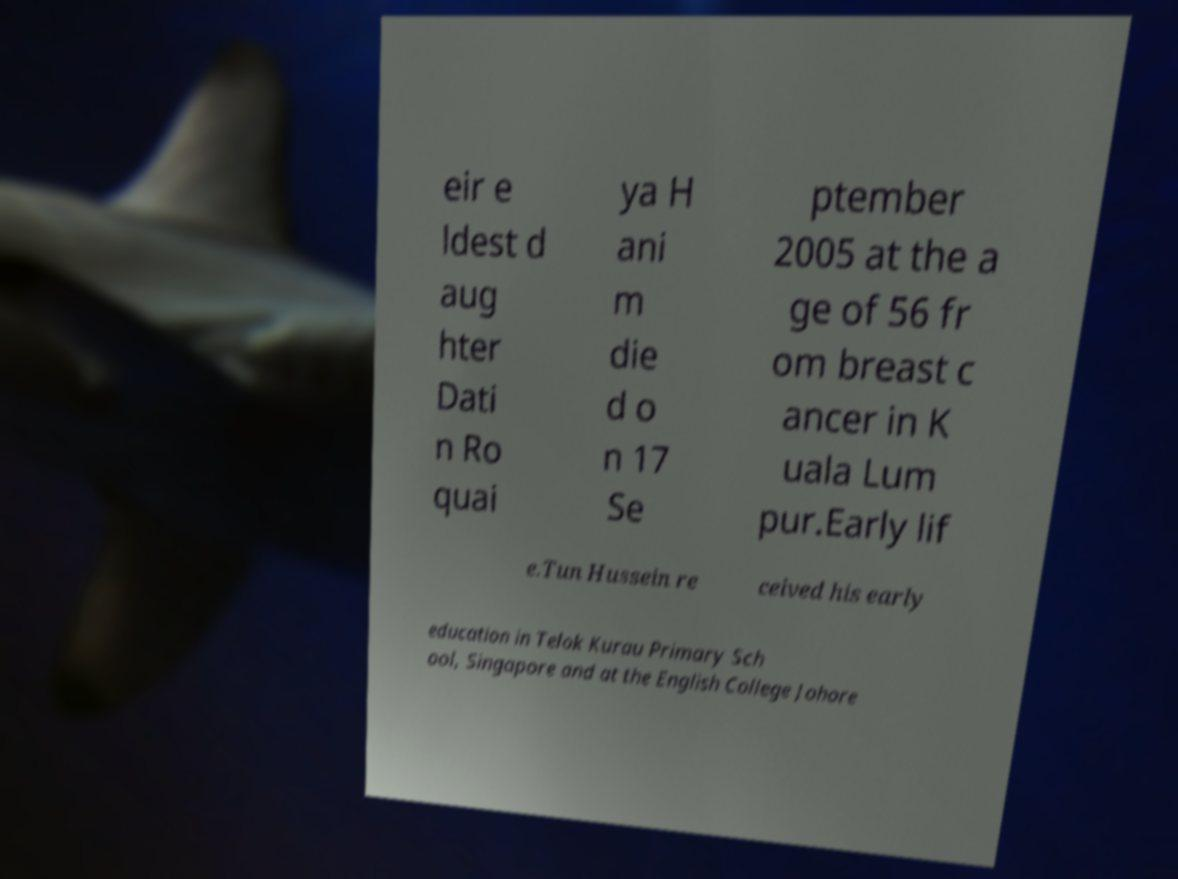Can you read and provide the text displayed in the image?This photo seems to have some interesting text. Can you extract and type it out for me? eir e ldest d aug hter Dati n Ro quai ya H ani m die d o n 17 Se ptember 2005 at the a ge of 56 fr om breast c ancer in K uala Lum pur.Early lif e.Tun Hussein re ceived his early education in Telok Kurau Primary Sch ool, Singapore and at the English College Johore 